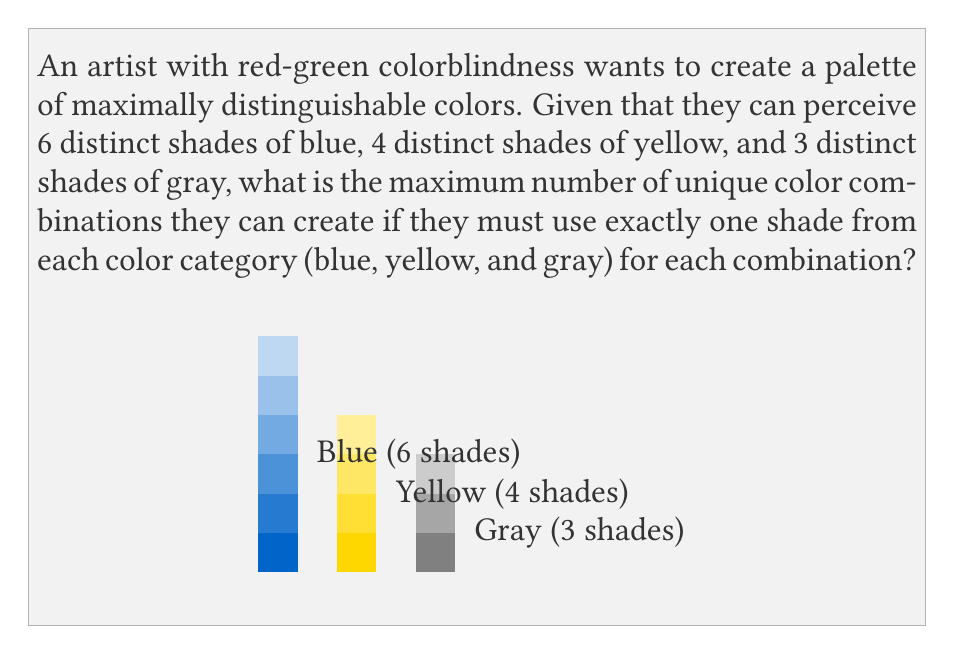Can you solve this math problem? To solve this problem, we can use the multiplication principle from combinatorics. The steps are as follows:

1) We need to choose one shade from each color category:
   - 6 choices for blue
   - 4 choices for yellow
   - 3 choices for gray

2) For each choice of blue, we can choose any of the 4 yellows, and for each of these blue-yellow combinations, we can choose any of the 3 grays.

3) Therefore, the total number of unique combinations is the product of the number of choices for each color:

   $$ \text{Total combinations} = 6 \times 4 \times 3 $$

4) Calculating this:
   $$ 6 \times 4 \times 3 = 24 \times 3 = 72 $$

Thus, the artist can create a maximum of 72 unique color combinations using this method.

This approach ensures that each combination is distinct from the others, as it differs in at least one of the three color components. It maximizes the use of the artist's ability to distinguish between the available shades in each color category, despite their red-green colorblindness.
Answer: 72 combinations 